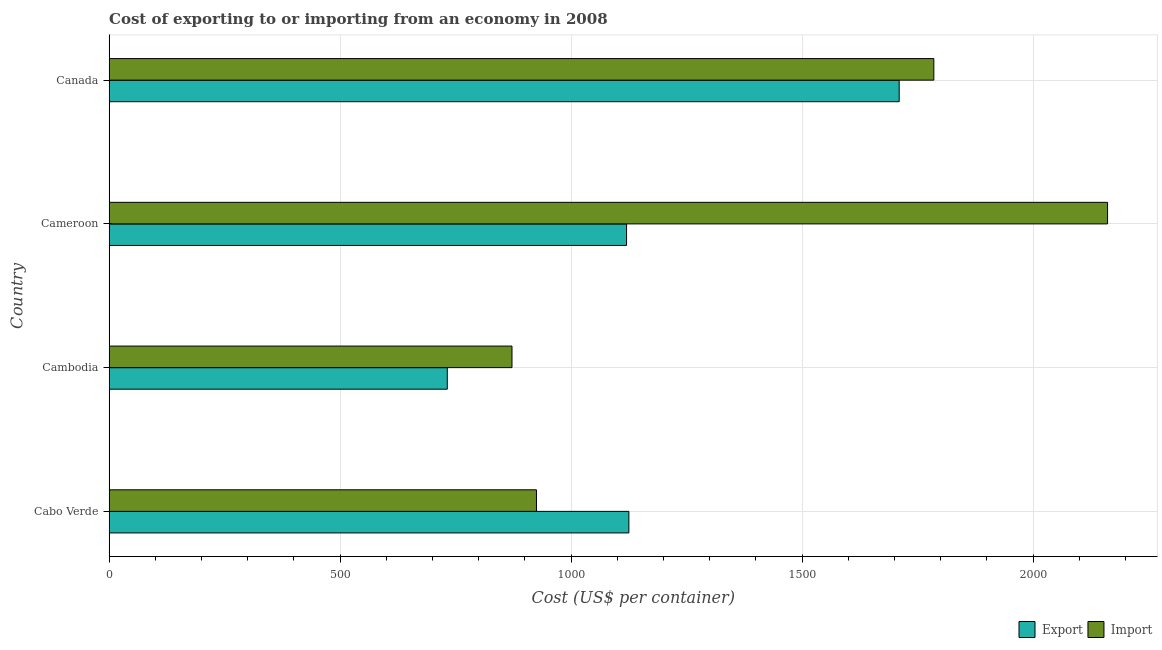How many different coloured bars are there?
Your response must be concise. 2. Are the number of bars per tick equal to the number of legend labels?
Give a very brief answer. Yes. How many bars are there on the 3rd tick from the top?
Keep it short and to the point. 2. How many bars are there on the 1st tick from the bottom?
Your answer should be compact. 2. What is the label of the 4th group of bars from the top?
Give a very brief answer. Cabo Verde. What is the import cost in Canada?
Ensure brevity in your answer.  1785. Across all countries, what is the maximum export cost?
Your response must be concise. 1710. Across all countries, what is the minimum import cost?
Keep it short and to the point. 872. In which country was the import cost maximum?
Ensure brevity in your answer.  Cameroon. In which country was the export cost minimum?
Provide a succinct answer. Cambodia. What is the total export cost in the graph?
Your response must be concise. 4687. What is the difference between the import cost in Cabo Verde and that in Cameroon?
Provide a short and direct response. -1236. What is the difference between the export cost in Canada and the import cost in Cambodia?
Offer a terse response. 838. What is the average export cost per country?
Make the answer very short. 1171.75. What is the difference between the export cost and import cost in Cabo Verde?
Your answer should be compact. 200. In how many countries, is the export cost greater than 200 US$?
Provide a short and direct response. 4. What is the ratio of the import cost in Cabo Verde to that in Canada?
Provide a short and direct response. 0.52. Is the difference between the export cost in Cameroon and Canada greater than the difference between the import cost in Cameroon and Canada?
Your response must be concise. No. What is the difference between the highest and the second highest export cost?
Offer a terse response. 585. What is the difference between the highest and the lowest export cost?
Your answer should be compact. 978. Is the sum of the export cost in Cambodia and Canada greater than the maximum import cost across all countries?
Your response must be concise. Yes. What does the 2nd bar from the top in Cambodia represents?
Give a very brief answer. Export. What does the 2nd bar from the bottom in Cabo Verde represents?
Provide a short and direct response. Import. How many bars are there?
Keep it short and to the point. 8. Are all the bars in the graph horizontal?
Your answer should be compact. Yes. How many countries are there in the graph?
Provide a succinct answer. 4. Where does the legend appear in the graph?
Ensure brevity in your answer.  Bottom right. What is the title of the graph?
Your answer should be very brief. Cost of exporting to or importing from an economy in 2008. Does "Public funds" appear as one of the legend labels in the graph?
Your answer should be compact. No. What is the label or title of the X-axis?
Provide a short and direct response. Cost (US$ per container). What is the label or title of the Y-axis?
Offer a very short reply. Country. What is the Cost (US$ per container) of Export in Cabo Verde?
Keep it short and to the point. 1125. What is the Cost (US$ per container) of Import in Cabo Verde?
Offer a terse response. 925. What is the Cost (US$ per container) of Export in Cambodia?
Provide a succinct answer. 732. What is the Cost (US$ per container) of Import in Cambodia?
Your answer should be very brief. 872. What is the Cost (US$ per container) in Export in Cameroon?
Offer a terse response. 1120. What is the Cost (US$ per container) in Import in Cameroon?
Keep it short and to the point. 2161. What is the Cost (US$ per container) of Export in Canada?
Make the answer very short. 1710. What is the Cost (US$ per container) of Import in Canada?
Your answer should be very brief. 1785. Across all countries, what is the maximum Cost (US$ per container) of Export?
Keep it short and to the point. 1710. Across all countries, what is the maximum Cost (US$ per container) in Import?
Provide a succinct answer. 2161. Across all countries, what is the minimum Cost (US$ per container) of Export?
Your response must be concise. 732. Across all countries, what is the minimum Cost (US$ per container) in Import?
Keep it short and to the point. 872. What is the total Cost (US$ per container) of Export in the graph?
Your answer should be very brief. 4687. What is the total Cost (US$ per container) of Import in the graph?
Your answer should be very brief. 5743. What is the difference between the Cost (US$ per container) of Export in Cabo Verde and that in Cambodia?
Your answer should be very brief. 393. What is the difference between the Cost (US$ per container) in Import in Cabo Verde and that in Cameroon?
Your answer should be very brief. -1236. What is the difference between the Cost (US$ per container) in Export in Cabo Verde and that in Canada?
Offer a very short reply. -585. What is the difference between the Cost (US$ per container) of Import in Cabo Verde and that in Canada?
Keep it short and to the point. -860. What is the difference between the Cost (US$ per container) in Export in Cambodia and that in Cameroon?
Offer a very short reply. -388. What is the difference between the Cost (US$ per container) in Import in Cambodia and that in Cameroon?
Your answer should be compact. -1289. What is the difference between the Cost (US$ per container) in Export in Cambodia and that in Canada?
Make the answer very short. -978. What is the difference between the Cost (US$ per container) in Import in Cambodia and that in Canada?
Offer a terse response. -913. What is the difference between the Cost (US$ per container) of Export in Cameroon and that in Canada?
Provide a succinct answer. -590. What is the difference between the Cost (US$ per container) in Import in Cameroon and that in Canada?
Make the answer very short. 376. What is the difference between the Cost (US$ per container) in Export in Cabo Verde and the Cost (US$ per container) in Import in Cambodia?
Provide a succinct answer. 253. What is the difference between the Cost (US$ per container) in Export in Cabo Verde and the Cost (US$ per container) in Import in Cameroon?
Offer a terse response. -1036. What is the difference between the Cost (US$ per container) of Export in Cabo Verde and the Cost (US$ per container) of Import in Canada?
Your answer should be very brief. -660. What is the difference between the Cost (US$ per container) of Export in Cambodia and the Cost (US$ per container) of Import in Cameroon?
Provide a succinct answer. -1429. What is the difference between the Cost (US$ per container) in Export in Cambodia and the Cost (US$ per container) in Import in Canada?
Give a very brief answer. -1053. What is the difference between the Cost (US$ per container) of Export in Cameroon and the Cost (US$ per container) of Import in Canada?
Your answer should be very brief. -665. What is the average Cost (US$ per container) in Export per country?
Give a very brief answer. 1171.75. What is the average Cost (US$ per container) in Import per country?
Offer a terse response. 1435.75. What is the difference between the Cost (US$ per container) of Export and Cost (US$ per container) of Import in Cabo Verde?
Give a very brief answer. 200. What is the difference between the Cost (US$ per container) in Export and Cost (US$ per container) in Import in Cambodia?
Your answer should be very brief. -140. What is the difference between the Cost (US$ per container) in Export and Cost (US$ per container) in Import in Cameroon?
Keep it short and to the point. -1041. What is the difference between the Cost (US$ per container) in Export and Cost (US$ per container) in Import in Canada?
Your answer should be compact. -75. What is the ratio of the Cost (US$ per container) in Export in Cabo Verde to that in Cambodia?
Provide a short and direct response. 1.54. What is the ratio of the Cost (US$ per container) of Import in Cabo Verde to that in Cambodia?
Give a very brief answer. 1.06. What is the ratio of the Cost (US$ per container) in Export in Cabo Verde to that in Cameroon?
Offer a terse response. 1. What is the ratio of the Cost (US$ per container) in Import in Cabo Verde to that in Cameroon?
Provide a succinct answer. 0.43. What is the ratio of the Cost (US$ per container) of Export in Cabo Verde to that in Canada?
Offer a very short reply. 0.66. What is the ratio of the Cost (US$ per container) of Import in Cabo Verde to that in Canada?
Keep it short and to the point. 0.52. What is the ratio of the Cost (US$ per container) in Export in Cambodia to that in Cameroon?
Your answer should be compact. 0.65. What is the ratio of the Cost (US$ per container) in Import in Cambodia to that in Cameroon?
Give a very brief answer. 0.4. What is the ratio of the Cost (US$ per container) in Export in Cambodia to that in Canada?
Your answer should be very brief. 0.43. What is the ratio of the Cost (US$ per container) of Import in Cambodia to that in Canada?
Provide a short and direct response. 0.49. What is the ratio of the Cost (US$ per container) of Export in Cameroon to that in Canada?
Provide a short and direct response. 0.66. What is the ratio of the Cost (US$ per container) of Import in Cameroon to that in Canada?
Provide a short and direct response. 1.21. What is the difference between the highest and the second highest Cost (US$ per container) of Export?
Provide a succinct answer. 585. What is the difference between the highest and the second highest Cost (US$ per container) in Import?
Offer a very short reply. 376. What is the difference between the highest and the lowest Cost (US$ per container) of Export?
Provide a succinct answer. 978. What is the difference between the highest and the lowest Cost (US$ per container) in Import?
Ensure brevity in your answer.  1289. 